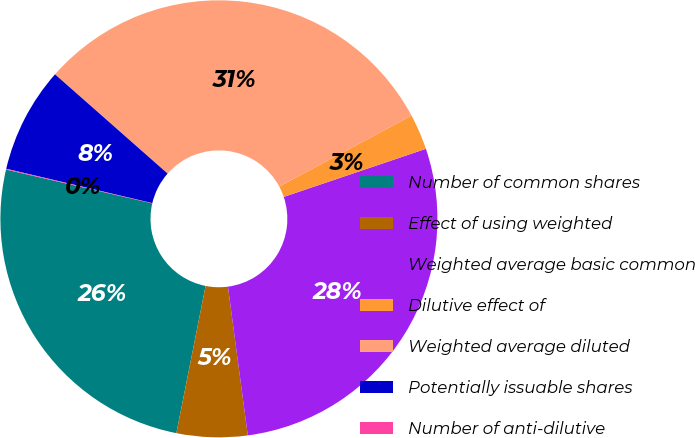Convert chart. <chart><loc_0><loc_0><loc_500><loc_500><pie_chart><fcel>Number of common shares<fcel>Effect of using weighted<fcel>Weighted average basic common<fcel>Dilutive effect of<fcel>Weighted average diluted<fcel>Potentially issuable shares<fcel>Number of anti-dilutive<nl><fcel>25.5%<fcel>5.23%<fcel>28.08%<fcel>2.64%<fcel>30.67%<fcel>7.82%<fcel>0.06%<nl></chart> 